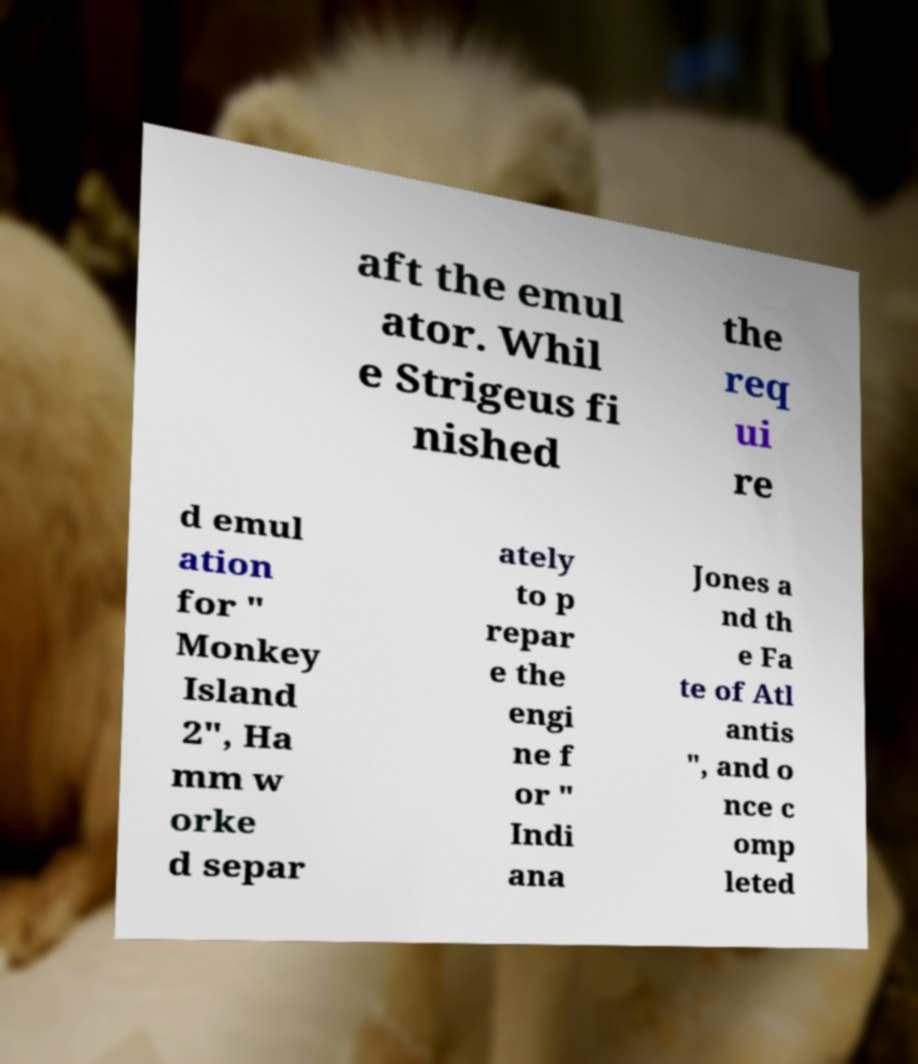What messages or text are displayed in this image? I need them in a readable, typed format. aft the emul ator. Whil e Strigeus fi nished the req ui re d emul ation for " Monkey Island 2", Ha mm w orke d separ ately to p repar e the engi ne f or " Indi ana Jones a nd th e Fa te of Atl antis ", and o nce c omp leted 